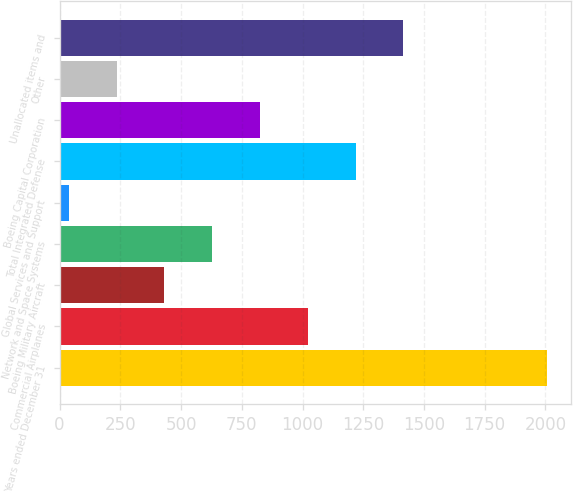Convert chart. <chart><loc_0><loc_0><loc_500><loc_500><bar_chart><fcel>Years ended December 31<fcel>Commercial Airplanes<fcel>Boeing Military Aircraft<fcel>Network and Space Systems<fcel>Global Services and Support<fcel>Total Integrated Defense<fcel>Boeing Capital Corporation<fcel>Other<fcel>Unallocated items and<nl><fcel>2006<fcel>1022<fcel>431.6<fcel>628.4<fcel>38<fcel>1218.8<fcel>825.2<fcel>234.8<fcel>1415.6<nl></chart> 